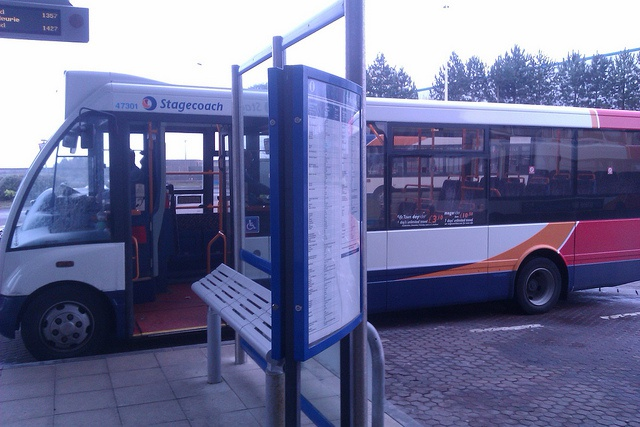Describe the objects in this image and their specific colors. I can see bus in blue, navy, black, gray, and darkgray tones, people in blue, navy, and darkblue tones, and people in blue, navy, white, and darkblue tones in this image. 